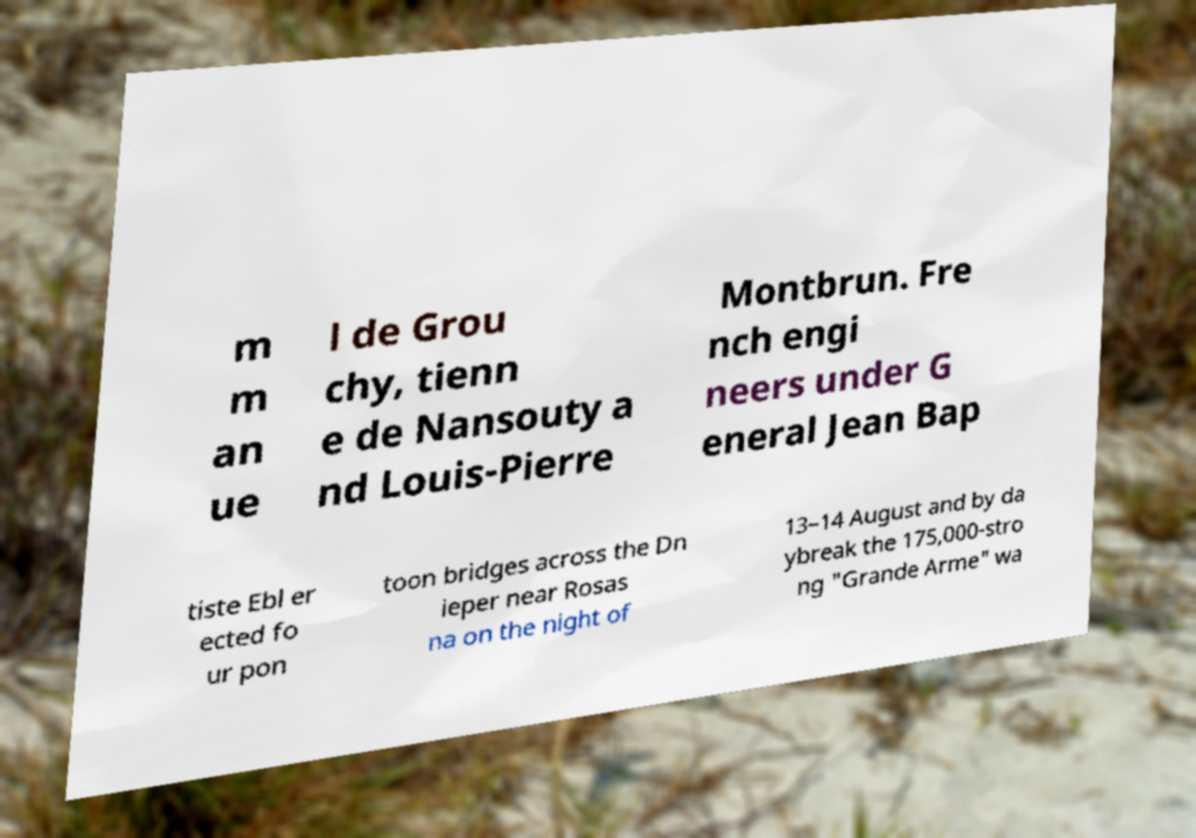For documentation purposes, I need the text within this image transcribed. Could you provide that? m m an ue l de Grou chy, tienn e de Nansouty a nd Louis-Pierre Montbrun. Fre nch engi neers under G eneral Jean Bap tiste Ebl er ected fo ur pon toon bridges across the Dn ieper near Rosas na on the night of 13–14 August and by da ybreak the 175,000-stro ng "Grande Arme" wa 